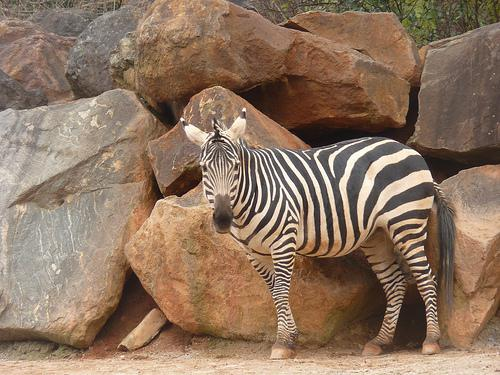Question: what animal is in the photo?
Choices:
A. A horse.
B. A cat.
C. A zebra.
D. A dog.
Answer with the letter. Answer: C Question: what is the zebra doing?
Choices:
A. Grazing.
B. Running.
C. Looking at the camera.
D. Walking.
Answer with the letter. Answer: C Question: when was the photo taken?
Choices:
A. In the daytime.
B. In the evening.
C. In the morning.
D. In the afternoon.
Answer with the letter. Answer: A 